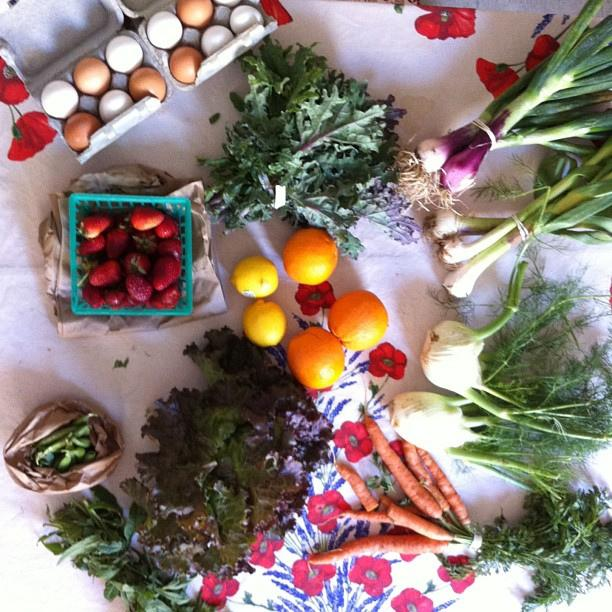What is the orange item near the bottom of the pile? carrot 